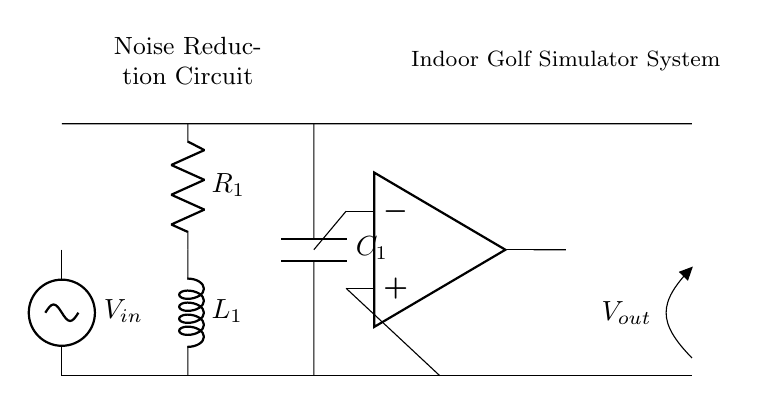What is the input voltage in the circuit? The input voltage is labeled as \( V_{in} \) in the circuit diagram, which indicates the source voltage supplying the RLC circuit.
Answer: \( V_{in} \) What type of circuit does this diagram represent? The diagram represents a noise reduction circuit using resistors, inductors, and capacitors, which is typical of RLC circuits.
Answer: RLC circuit How many components are in the circuit? The circuit has four main components: a resistor, an inductor, a capacitor, and an operational amplifier.
Answer: Four What is the purpose of the operational amplifier in this circuit? The operational amplifier is used to amplify the filtered signal after it passes through the RLC components, thus improving the signal quality for the output.
Answer: Signal amplification What is the role of the capacitor in the noise reduction circuit? The capacitor is used to filter high-frequency noise from the input signal, allowing only the desired low-frequency components to pass through to the output.
Answer: Filtering high-frequency noise In what configuration are the resistor, inductor, and capacitor connected? The resistor and inductor are arranged in series with the capacitor connected in parallel to the output at the specified configuration, forming a typical RLC filter circuit.
Answer: Series and parallel configuration What is the output voltage notation in the circuit? The output voltage is labeled as \( V_{out} \), indicating the voltage that has been processed and filtered by the components in the circuit.
Answer: \( V_{out} \) 